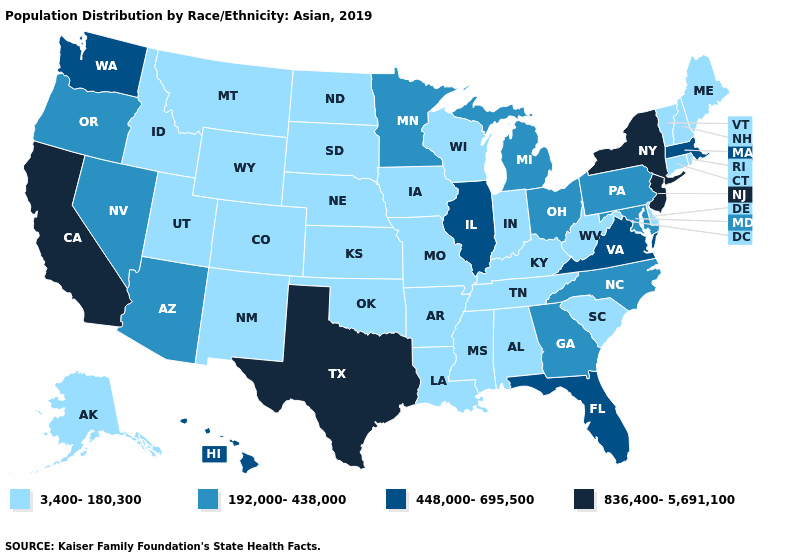Name the states that have a value in the range 836,400-5,691,100?
Give a very brief answer. California, New Jersey, New York, Texas. Name the states that have a value in the range 448,000-695,500?
Answer briefly. Florida, Hawaii, Illinois, Massachusetts, Virginia, Washington. What is the value of Wyoming?
Be succinct. 3,400-180,300. Does North Carolina have the lowest value in the USA?
Give a very brief answer. No. What is the lowest value in the Northeast?
Keep it brief. 3,400-180,300. Among the states that border Connecticut , which have the lowest value?
Be succinct. Rhode Island. Among the states that border West Virginia , which have the lowest value?
Concise answer only. Kentucky. Name the states that have a value in the range 448,000-695,500?
Give a very brief answer. Florida, Hawaii, Illinois, Massachusetts, Virginia, Washington. Name the states that have a value in the range 836,400-5,691,100?
Give a very brief answer. California, New Jersey, New York, Texas. What is the lowest value in the South?
Answer briefly. 3,400-180,300. Does Virginia have the highest value in the USA?
Quick response, please. No. Name the states that have a value in the range 3,400-180,300?
Quick response, please. Alabama, Alaska, Arkansas, Colorado, Connecticut, Delaware, Idaho, Indiana, Iowa, Kansas, Kentucky, Louisiana, Maine, Mississippi, Missouri, Montana, Nebraska, New Hampshire, New Mexico, North Dakota, Oklahoma, Rhode Island, South Carolina, South Dakota, Tennessee, Utah, Vermont, West Virginia, Wisconsin, Wyoming. Does Wisconsin have the lowest value in the USA?
Quick response, please. Yes. Name the states that have a value in the range 448,000-695,500?
Keep it brief. Florida, Hawaii, Illinois, Massachusetts, Virginia, Washington. Which states have the lowest value in the South?
Answer briefly. Alabama, Arkansas, Delaware, Kentucky, Louisiana, Mississippi, Oklahoma, South Carolina, Tennessee, West Virginia. 